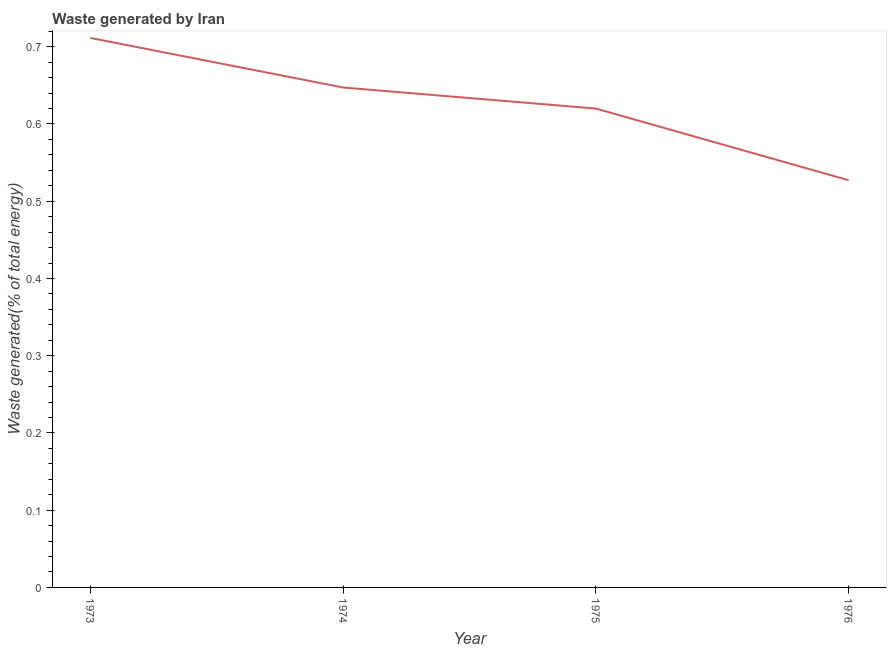What is the amount of waste generated in 1974?
Provide a succinct answer. 0.65. Across all years, what is the maximum amount of waste generated?
Provide a succinct answer. 0.71. Across all years, what is the minimum amount of waste generated?
Offer a very short reply. 0.53. In which year was the amount of waste generated minimum?
Offer a terse response. 1976. What is the sum of the amount of waste generated?
Make the answer very short. 2.51. What is the difference between the amount of waste generated in 1975 and 1976?
Offer a very short reply. 0.09. What is the average amount of waste generated per year?
Give a very brief answer. 0.63. What is the median amount of waste generated?
Keep it short and to the point. 0.63. What is the ratio of the amount of waste generated in 1973 to that in 1974?
Your answer should be very brief. 1.1. Is the difference between the amount of waste generated in 1975 and 1976 greater than the difference between any two years?
Your answer should be very brief. No. What is the difference between the highest and the second highest amount of waste generated?
Keep it short and to the point. 0.06. What is the difference between the highest and the lowest amount of waste generated?
Keep it short and to the point. 0.18. How many lines are there?
Provide a short and direct response. 1. How many years are there in the graph?
Keep it short and to the point. 4. Does the graph contain grids?
Your answer should be compact. No. What is the title of the graph?
Give a very brief answer. Waste generated by Iran. What is the label or title of the Y-axis?
Offer a terse response. Waste generated(% of total energy). What is the Waste generated(% of total energy) of 1973?
Your response must be concise. 0.71. What is the Waste generated(% of total energy) of 1974?
Give a very brief answer. 0.65. What is the Waste generated(% of total energy) of 1975?
Offer a very short reply. 0.62. What is the Waste generated(% of total energy) in 1976?
Provide a succinct answer. 0.53. What is the difference between the Waste generated(% of total energy) in 1973 and 1974?
Give a very brief answer. 0.06. What is the difference between the Waste generated(% of total energy) in 1973 and 1975?
Offer a very short reply. 0.09. What is the difference between the Waste generated(% of total energy) in 1973 and 1976?
Provide a short and direct response. 0.18. What is the difference between the Waste generated(% of total energy) in 1974 and 1975?
Make the answer very short. 0.03. What is the difference between the Waste generated(% of total energy) in 1974 and 1976?
Give a very brief answer. 0.12. What is the difference between the Waste generated(% of total energy) in 1975 and 1976?
Provide a succinct answer. 0.09. What is the ratio of the Waste generated(% of total energy) in 1973 to that in 1974?
Keep it short and to the point. 1.1. What is the ratio of the Waste generated(% of total energy) in 1973 to that in 1975?
Provide a succinct answer. 1.15. What is the ratio of the Waste generated(% of total energy) in 1973 to that in 1976?
Your answer should be very brief. 1.35. What is the ratio of the Waste generated(% of total energy) in 1974 to that in 1975?
Keep it short and to the point. 1.04. What is the ratio of the Waste generated(% of total energy) in 1974 to that in 1976?
Provide a short and direct response. 1.23. What is the ratio of the Waste generated(% of total energy) in 1975 to that in 1976?
Offer a terse response. 1.18. 